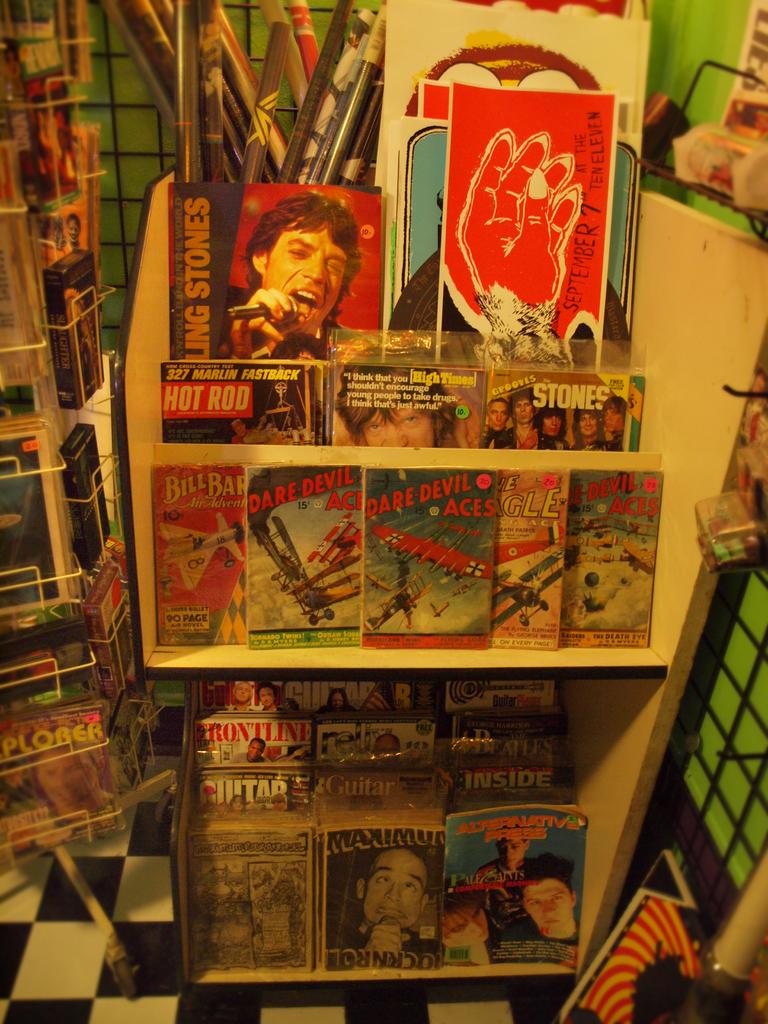Which comic book hero is on the middle shelf?
Make the answer very short. Dare devil aces. The portrait is on the red cover?
Give a very brief answer. Answering does not require reading text in the image. 